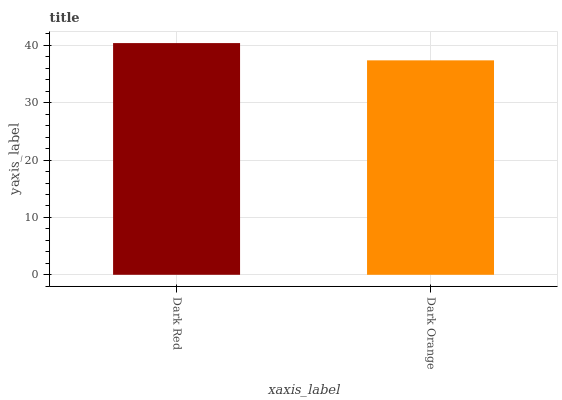Is Dark Orange the minimum?
Answer yes or no. Yes. Is Dark Red the maximum?
Answer yes or no. Yes. Is Dark Orange the maximum?
Answer yes or no. No. Is Dark Red greater than Dark Orange?
Answer yes or no. Yes. Is Dark Orange less than Dark Red?
Answer yes or no. Yes. Is Dark Orange greater than Dark Red?
Answer yes or no. No. Is Dark Red less than Dark Orange?
Answer yes or no. No. Is Dark Red the high median?
Answer yes or no. Yes. Is Dark Orange the low median?
Answer yes or no. Yes. Is Dark Orange the high median?
Answer yes or no. No. Is Dark Red the low median?
Answer yes or no. No. 